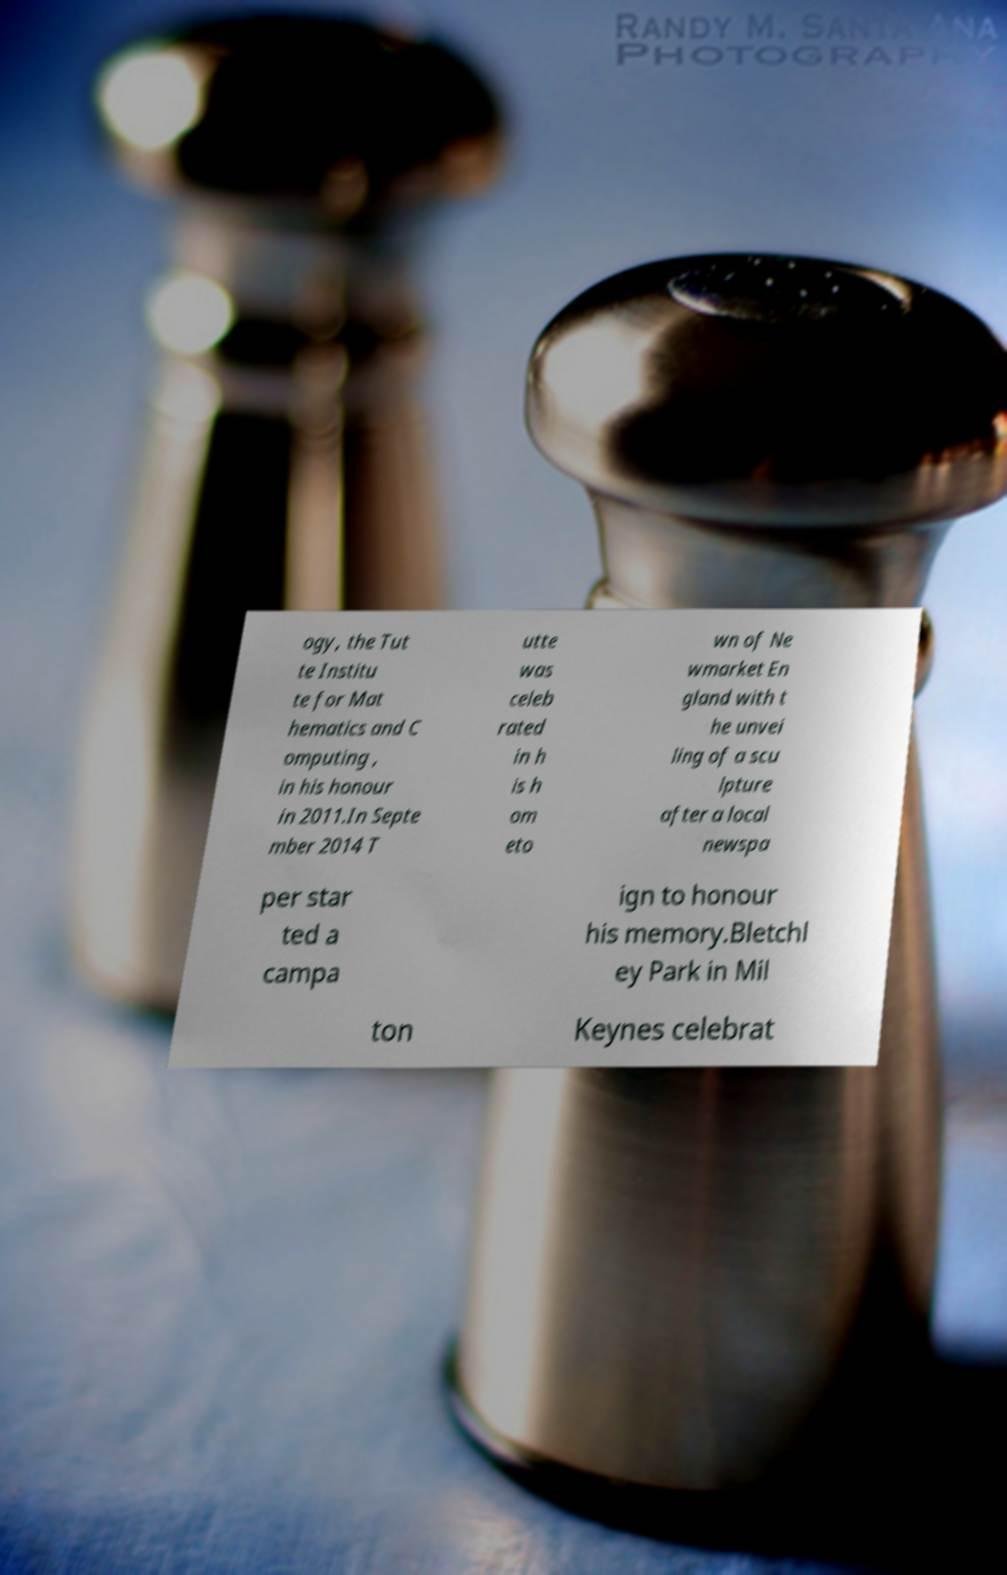Could you extract and type out the text from this image? ogy, the Tut te Institu te for Mat hematics and C omputing , in his honour in 2011.In Septe mber 2014 T utte was celeb rated in h is h om eto wn of Ne wmarket En gland with t he unvei ling of a scu lpture after a local newspa per star ted a campa ign to honour his memory.Bletchl ey Park in Mil ton Keynes celebrat 